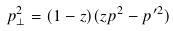Convert formula to latex. <formula><loc_0><loc_0><loc_500><loc_500>p ^ { 2 } _ { \perp } = ( 1 - z ) ( z p ^ { 2 } - p ^ { \prime 2 } ) \ \</formula> 